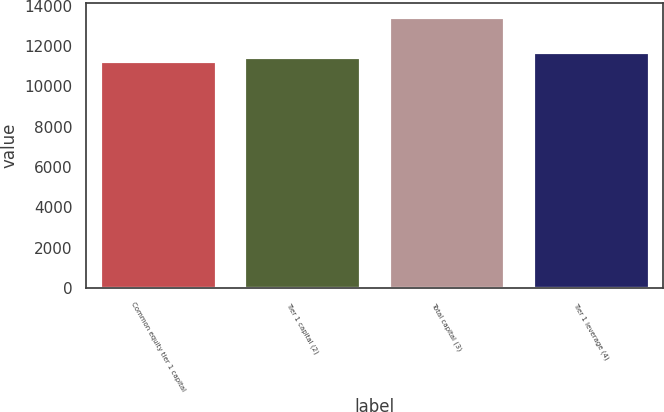<chart> <loc_0><loc_0><loc_500><loc_500><bar_chart><fcel>Common equity tier 1 capital<fcel>Tier 1 capital (2)<fcel>Total capital (3)<fcel>Tier 1 leverage (4)<nl><fcel>11248<fcel>11467.5<fcel>13443<fcel>11687<nl></chart> 